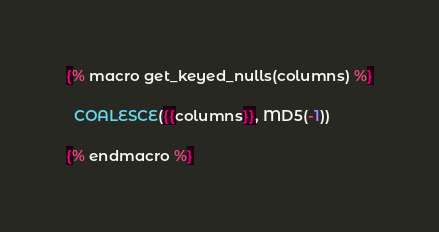<code> <loc_0><loc_0><loc_500><loc_500><_SQL_>{% macro get_keyed_nulls(columns) %}

  COALESCE({{columns}}, MD5(-1)) 

{% endmacro %}
</code> 